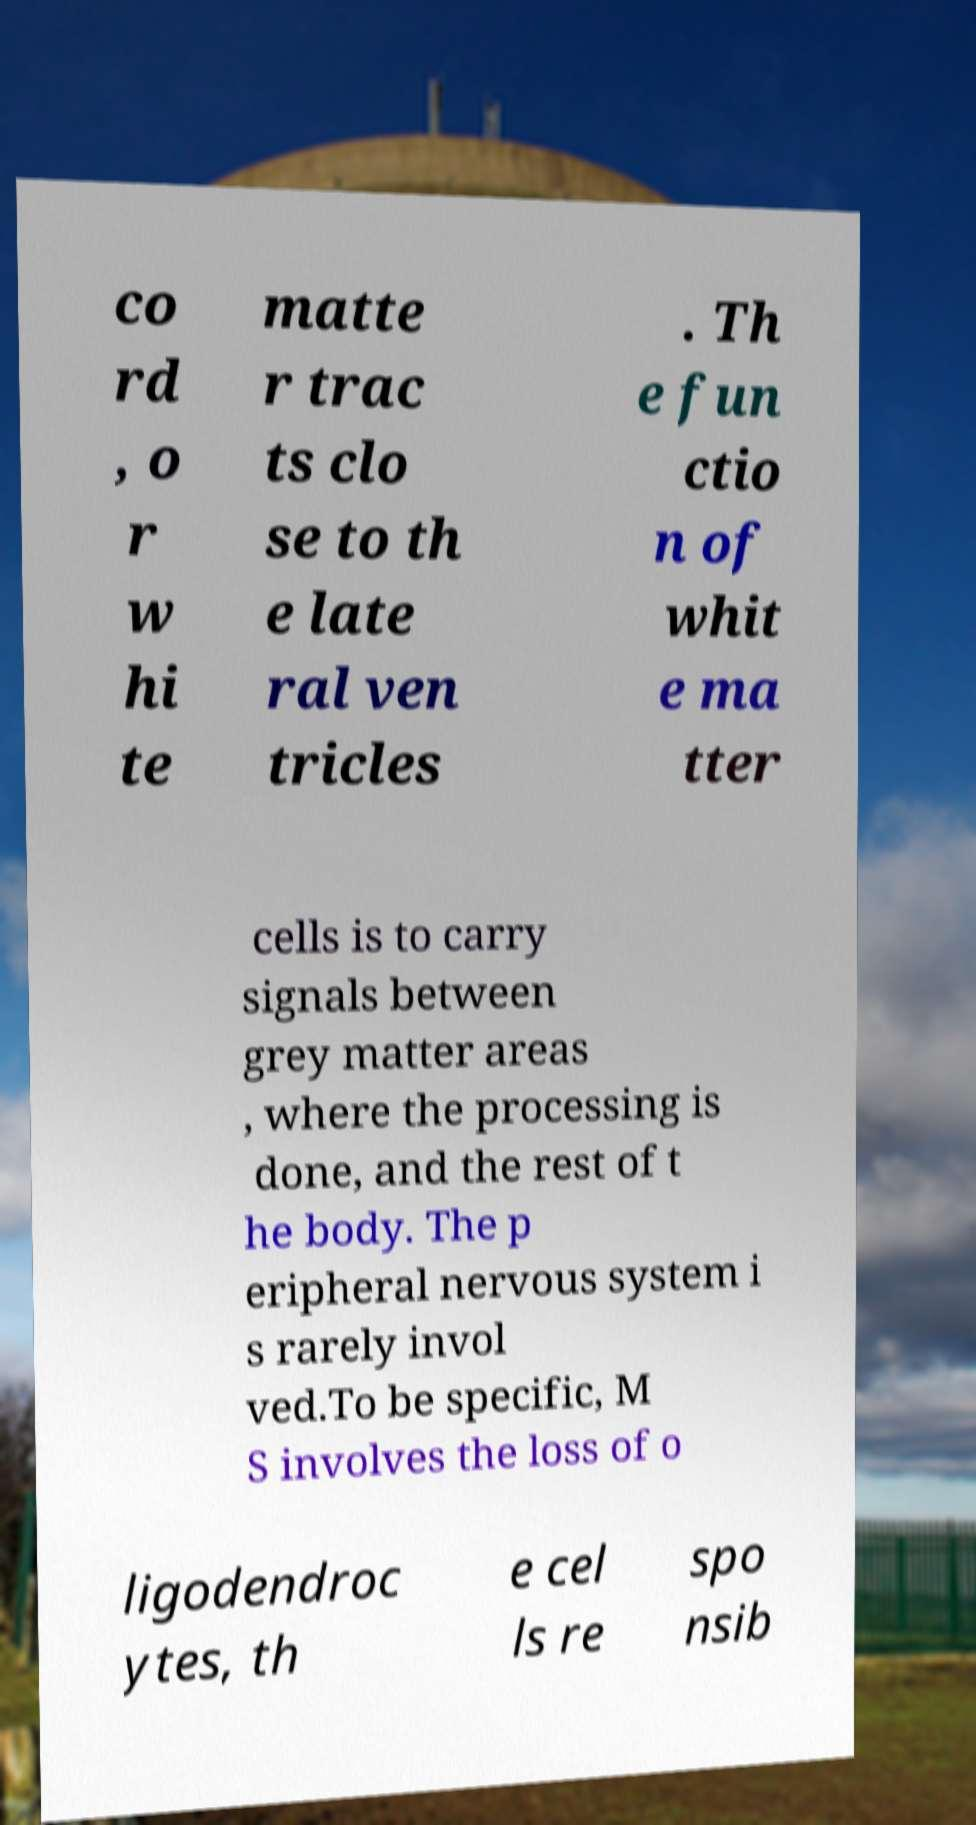I need the written content from this picture converted into text. Can you do that? co rd , o r w hi te matte r trac ts clo se to th e late ral ven tricles . Th e fun ctio n of whit e ma tter cells is to carry signals between grey matter areas , where the processing is done, and the rest of t he body. The p eripheral nervous system i s rarely invol ved.To be specific, M S involves the loss of o ligodendroc ytes, th e cel ls re spo nsib 